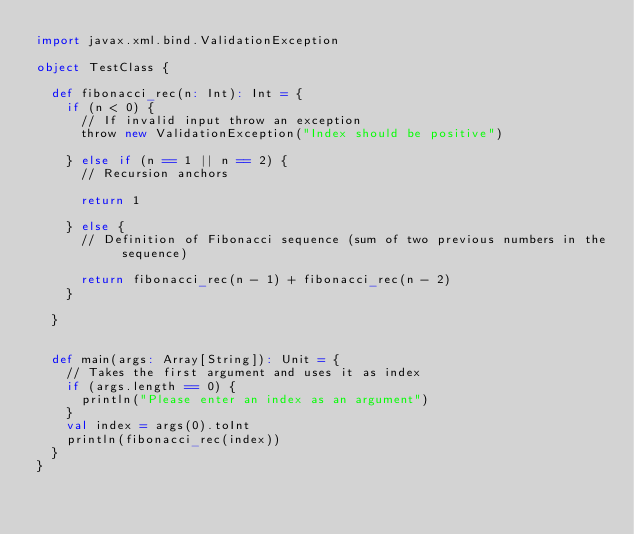<code> <loc_0><loc_0><loc_500><loc_500><_Scala_>import javax.xml.bind.ValidationException

object TestClass {

  def fibonacci_rec(n: Int): Int = {
    if (n < 0) {
      // If invalid input throw an exception
      throw new ValidationException("Index should be positive")

    } else if (n == 1 || n == 2) {
      // Recursion anchors

      return 1

    } else {
      // Definition of Fibonacci sequence (sum of two previous numbers in the sequence)

      return fibonacci_rec(n - 1) + fibonacci_rec(n - 2)
    }

  }


  def main(args: Array[String]): Unit = {
    // Takes the first argument and uses it as index
    if (args.length == 0) {
      println("Please enter an index as an argument")
    }
    val index = args(0).toInt
    println(fibonacci_rec(index))
  }
}
</code> 